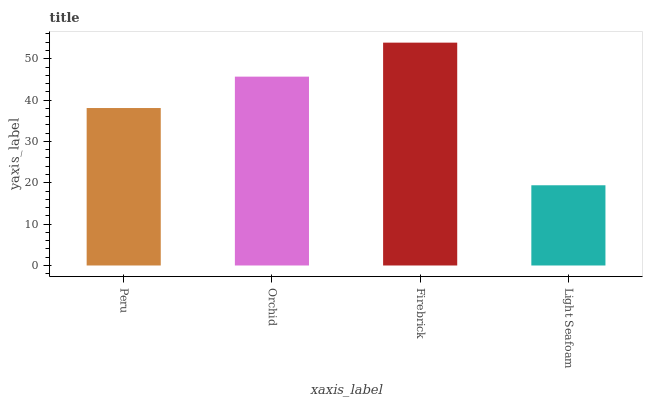Is Orchid the minimum?
Answer yes or no. No. Is Orchid the maximum?
Answer yes or no. No. Is Orchid greater than Peru?
Answer yes or no. Yes. Is Peru less than Orchid?
Answer yes or no. Yes. Is Peru greater than Orchid?
Answer yes or no. No. Is Orchid less than Peru?
Answer yes or no. No. Is Orchid the high median?
Answer yes or no. Yes. Is Peru the low median?
Answer yes or no. Yes. Is Firebrick the high median?
Answer yes or no. No. Is Light Seafoam the low median?
Answer yes or no. No. 